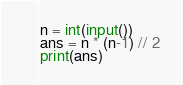Convert code to text. <code><loc_0><loc_0><loc_500><loc_500><_Python_>n = int(input())
ans = n * (n-1) // 2
print(ans)</code> 